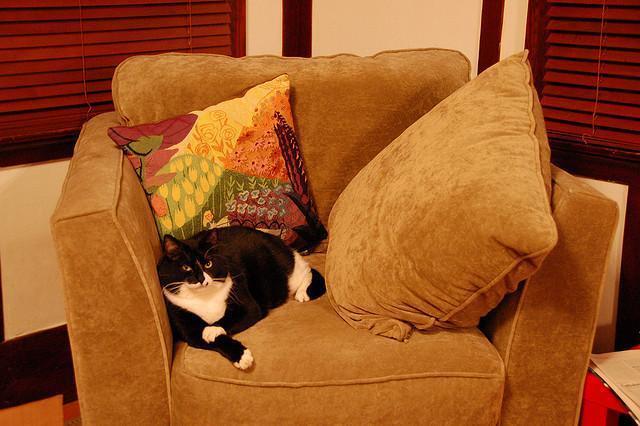How many elephant tails are showing?
Give a very brief answer. 0. 